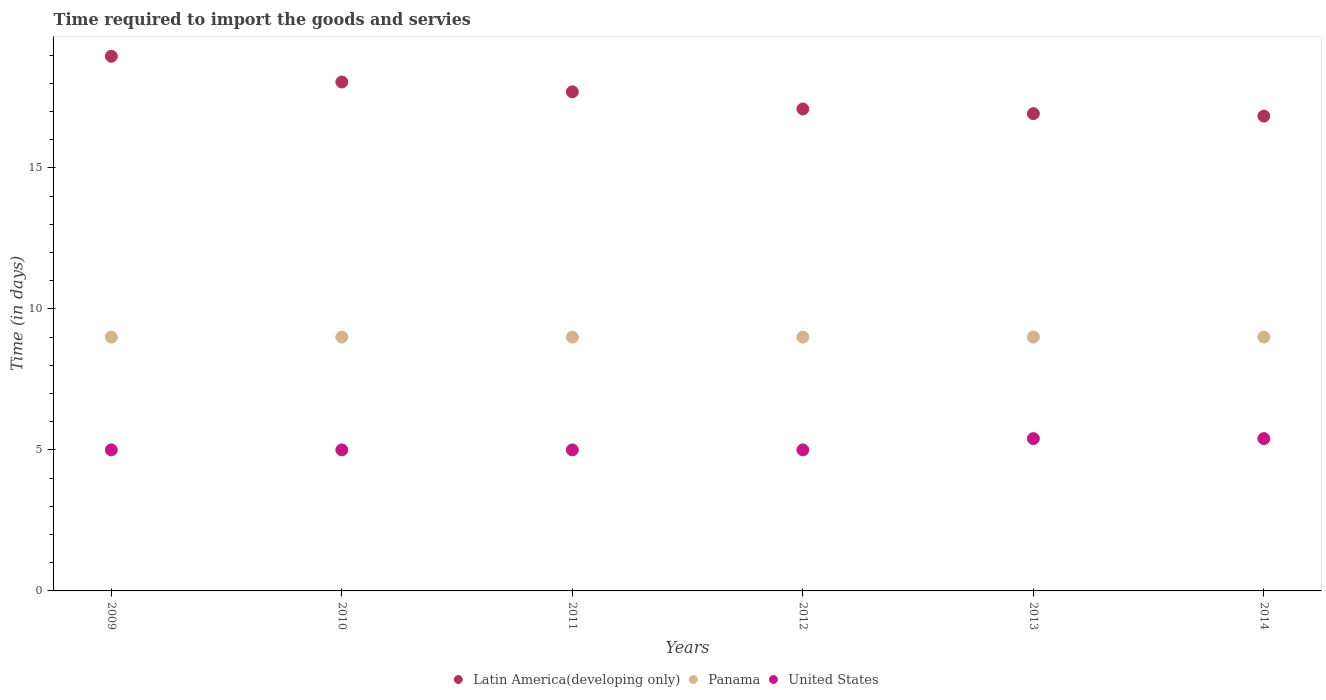How many different coloured dotlines are there?
Keep it short and to the point. 3. What is the number of days required to import the goods and services in Panama in 2009?
Give a very brief answer. 9. Across all years, what is the maximum number of days required to import the goods and services in Panama?
Provide a succinct answer. 9. Across all years, what is the minimum number of days required to import the goods and services in United States?
Give a very brief answer. 5. In which year was the number of days required to import the goods and services in United States maximum?
Make the answer very short. 2013. In which year was the number of days required to import the goods and services in Panama minimum?
Give a very brief answer. 2009. What is the total number of days required to import the goods and services in Latin America(developing only) in the graph?
Provide a succinct answer. 105.54. What is the difference between the number of days required to import the goods and services in Latin America(developing only) in 2011 and the number of days required to import the goods and services in Panama in 2013?
Keep it short and to the point. 8.7. What is the average number of days required to import the goods and services in Latin America(developing only) per year?
Provide a succinct answer. 17.59. In the year 2013, what is the difference between the number of days required to import the goods and services in United States and number of days required to import the goods and services in Latin America(developing only)?
Your response must be concise. -11.52. Is the number of days required to import the goods and services in United States in 2012 less than that in 2014?
Keep it short and to the point. Yes. What is the difference between the highest and the second highest number of days required to import the goods and services in United States?
Your response must be concise. 0. What is the difference between the highest and the lowest number of days required to import the goods and services in United States?
Make the answer very short. 0.4. In how many years, is the number of days required to import the goods and services in Latin America(developing only) greater than the average number of days required to import the goods and services in Latin America(developing only) taken over all years?
Provide a succinct answer. 3. Is the sum of the number of days required to import the goods and services in Panama in 2010 and 2012 greater than the maximum number of days required to import the goods and services in Latin America(developing only) across all years?
Keep it short and to the point. No. Is it the case that in every year, the sum of the number of days required to import the goods and services in United States and number of days required to import the goods and services in Panama  is greater than the number of days required to import the goods and services in Latin America(developing only)?
Give a very brief answer. No. Does the number of days required to import the goods and services in United States monotonically increase over the years?
Ensure brevity in your answer.  No. Is the number of days required to import the goods and services in Panama strictly less than the number of days required to import the goods and services in Latin America(developing only) over the years?
Offer a terse response. Yes. How many years are there in the graph?
Your response must be concise. 6. What is the difference between two consecutive major ticks on the Y-axis?
Keep it short and to the point. 5. Are the values on the major ticks of Y-axis written in scientific E-notation?
Keep it short and to the point. No. Does the graph contain grids?
Keep it short and to the point. No. What is the title of the graph?
Your answer should be very brief. Time required to import the goods and servies. Does "Middle income" appear as one of the legend labels in the graph?
Provide a short and direct response. No. What is the label or title of the Y-axis?
Ensure brevity in your answer.  Time (in days). What is the Time (in days) of Latin America(developing only) in 2009?
Ensure brevity in your answer.  18.96. What is the Time (in days) in Panama in 2009?
Offer a terse response. 9. What is the Time (in days) in United States in 2009?
Offer a very short reply. 5. What is the Time (in days) of Latin America(developing only) in 2010?
Make the answer very short. 18.04. What is the Time (in days) in Latin America(developing only) in 2011?
Offer a terse response. 17.7. What is the Time (in days) in United States in 2011?
Your response must be concise. 5. What is the Time (in days) of Latin America(developing only) in 2012?
Your answer should be compact. 17.09. What is the Time (in days) of Latin America(developing only) in 2013?
Provide a short and direct response. 16.92. What is the Time (in days) in Panama in 2013?
Provide a succinct answer. 9. What is the Time (in days) in United States in 2013?
Your answer should be very brief. 5.4. What is the Time (in days) in Latin America(developing only) in 2014?
Your answer should be compact. 16.83. What is the Time (in days) in Panama in 2014?
Your answer should be compact. 9. Across all years, what is the maximum Time (in days) in Latin America(developing only)?
Offer a terse response. 18.96. Across all years, what is the maximum Time (in days) in Panama?
Your response must be concise. 9. Across all years, what is the maximum Time (in days) in United States?
Offer a very short reply. 5.4. Across all years, what is the minimum Time (in days) of Latin America(developing only)?
Make the answer very short. 16.83. What is the total Time (in days) of Latin America(developing only) in the graph?
Provide a short and direct response. 105.54. What is the total Time (in days) of Panama in the graph?
Your response must be concise. 54. What is the total Time (in days) in United States in the graph?
Offer a very short reply. 30.8. What is the difference between the Time (in days) of Panama in 2009 and that in 2010?
Your answer should be very brief. 0. What is the difference between the Time (in days) in United States in 2009 and that in 2010?
Offer a terse response. 0. What is the difference between the Time (in days) of Latin America(developing only) in 2009 and that in 2011?
Offer a terse response. 1.26. What is the difference between the Time (in days) in Panama in 2009 and that in 2011?
Make the answer very short. 0. What is the difference between the Time (in days) in United States in 2009 and that in 2011?
Your response must be concise. 0. What is the difference between the Time (in days) in Latin America(developing only) in 2009 and that in 2012?
Provide a short and direct response. 1.87. What is the difference between the Time (in days) of Panama in 2009 and that in 2012?
Your answer should be compact. 0. What is the difference between the Time (in days) in Latin America(developing only) in 2009 and that in 2013?
Provide a short and direct response. 2.03. What is the difference between the Time (in days) in Latin America(developing only) in 2009 and that in 2014?
Keep it short and to the point. 2.12. What is the difference between the Time (in days) of Latin America(developing only) in 2010 and that in 2011?
Provide a short and direct response. 0.35. What is the difference between the Time (in days) in United States in 2010 and that in 2011?
Your answer should be compact. 0. What is the difference between the Time (in days) of Latin America(developing only) in 2010 and that in 2012?
Your answer should be very brief. 0.96. What is the difference between the Time (in days) of United States in 2010 and that in 2012?
Offer a very short reply. 0. What is the difference between the Time (in days) in Latin America(developing only) in 2010 and that in 2013?
Provide a succinct answer. 1.12. What is the difference between the Time (in days) in Panama in 2010 and that in 2013?
Give a very brief answer. 0. What is the difference between the Time (in days) in Latin America(developing only) in 2010 and that in 2014?
Give a very brief answer. 1.21. What is the difference between the Time (in days) in Panama in 2010 and that in 2014?
Keep it short and to the point. 0. What is the difference between the Time (in days) of Latin America(developing only) in 2011 and that in 2012?
Make the answer very short. 0.61. What is the difference between the Time (in days) of Panama in 2011 and that in 2012?
Offer a terse response. 0. What is the difference between the Time (in days) in United States in 2011 and that in 2012?
Give a very brief answer. 0. What is the difference between the Time (in days) in Latin America(developing only) in 2011 and that in 2013?
Offer a very short reply. 0.77. What is the difference between the Time (in days) in United States in 2011 and that in 2013?
Give a very brief answer. -0.4. What is the difference between the Time (in days) of Latin America(developing only) in 2011 and that in 2014?
Your answer should be very brief. 0.86. What is the difference between the Time (in days) of Latin America(developing only) in 2012 and that in 2013?
Ensure brevity in your answer.  0.17. What is the difference between the Time (in days) of United States in 2012 and that in 2013?
Your response must be concise. -0.4. What is the difference between the Time (in days) of Latin America(developing only) in 2012 and that in 2014?
Your answer should be very brief. 0.25. What is the difference between the Time (in days) of Panama in 2012 and that in 2014?
Your answer should be compact. 0. What is the difference between the Time (in days) of Latin America(developing only) in 2013 and that in 2014?
Your answer should be compact. 0.09. What is the difference between the Time (in days) in Panama in 2013 and that in 2014?
Provide a short and direct response. 0. What is the difference between the Time (in days) of United States in 2013 and that in 2014?
Your answer should be compact. 0. What is the difference between the Time (in days) in Latin America(developing only) in 2009 and the Time (in days) in Panama in 2010?
Give a very brief answer. 9.96. What is the difference between the Time (in days) of Latin America(developing only) in 2009 and the Time (in days) of United States in 2010?
Your answer should be compact. 13.96. What is the difference between the Time (in days) of Latin America(developing only) in 2009 and the Time (in days) of Panama in 2011?
Your answer should be very brief. 9.96. What is the difference between the Time (in days) of Latin America(developing only) in 2009 and the Time (in days) of United States in 2011?
Offer a terse response. 13.96. What is the difference between the Time (in days) of Panama in 2009 and the Time (in days) of United States in 2011?
Your response must be concise. 4. What is the difference between the Time (in days) of Latin America(developing only) in 2009 and the Time (in days) of Panama in 2012?
Your response must be concise. 9.96. What is the difference between the Time (in days) in Latin America(developing only) in 2009 and the Time (in days) in United States in 2012?
Keep it short and to the point. 13.96. What is the difference between the Time (in days) in Latin America(developing only) in 2009 and the Time (in days) in Panama in 2013?
Provide a succinct answer. 9.96. What is the difference between the Time (in days) of Latin America(developing only) in 2009 and the Time (in days) of United States in 2013?
Offer a very short reply. 13.56. What is the difference between the Time (in days) in Latin America(developing only) in 2009 and the Time (in days) in Panama in 2014?
Your answer should be compact. 9.96. What is the difference between the Time (in days) of Latin America(developing only) in 2009 and the Time (in days) of United States in 2014?
Provide a short and direct response. 13.56. What is the difference between the Time (in days) of Panama in 2009 and the Time (in days) of United States in 2014?
Offer a terse response. 3.6. What is the difference between the Time (in days) in Latin America(developing only) in 2010 and the Time (in days) in Panama in 2011?
Keep it short and to the point. 9.04. What is the difference between the Time (in days) of Latin America(developing only) in 2010 and the Time (in days) of United States in 2011?
Provide a succinct answer. 13.04. What is the difference between the Time (in days) in Latin America(developing only) in 2010 and the Time (in days) in Panama in 2012?
Keep it short and to the point. 9.04. What is the difference between the Time (in days) in Latin America(developing only) in 2010 and the Time (in days) in United States in 2012?
Make the answer very short. 13.04. What is the difference between the Time (in days) of Panama in 2010 and the Time (in days) of United States in 2012?
Give a very brief answer. 4. What is the difference between the Time (in days) of Latin America(developing only) in 2010 and the Time (in days) of Panama in 2013?
Make the answer very short. 9.04. What is the difference between the Time (in days) in Latin America(developing only) in 2010 and the Time (in days) in United States in 2013?
Your answer should be compact. 12.64. What is the difference between the Time (in days) in Latin America(developing only) in 2010 and the Time (in days) in Panama in 2014?
Offer a terse response. 9.04. What is the difference between the Time (in days) in Latin America(developing only) in 2010 and the Time (in days) in United States in 2014?
Offer a terse response. 12.64. What is the difference between the Time (in days) of Latin America(developing only) in 2011 and the Time (in days) of Panama in 2012?
Offer a terse response. 8.7. What is the difference between the Time (in days) in Latin America(developing only) in 2011 and the Time (in days) in United States in 2012?
Offer a terse response. 12.7. What is the difference between the Time (in days) of Panama in 2011 and the Time (in days) of United States in 2012?
Keep it short and to the point. 4. What is the difference between the Time (in days) in Latin America(developing only) in 2011 and the Time (in days) in Panama in 2013?
Provide a short and direct response. 8.7. What is the difference between the Time (in days) of Latin America(developing only) in 2011 and the Time (in days) of United States in 2013?
Make the answer very short. 12.3. What is the difference between the Time (in days) of Panama in 2011 and the Time (in days) of United States in 2013?
Make the answer very short. 3.6. What is the difference between the Time (in days) in Latin America(developing only) in 2011 and the Time (in days) in Panama in 2014?
Offer a very short reply. 8.7. What is the difference between the Time (in days) of Latin America(developing only) in 2011 and the Time (in days) of United States in 2014?
Offer a very short reply. 12.3. What is the difference between the Time (in days) in Panama in 2011 and the Time (in days) in United States in 2014?
Make the answer very short. 3.6. What is the difference between the Time (in days) in Latin America(developing only) in 2012 and the Time (in days) in Panama in 2013?
Your response must be concise. 8.09. What is the difference between the Time (in days) in Latin America(developing only) in 2012 and the Time (in days) in United States in 2013?
Keep it short and to the point. 11.69. What is the difference between the Time (in days) of Latin America(developing only) in 2012 and the Time (in days) of Panama in 2014?
Your answer should be very brief. 8.09. What is the difference between the Time (in days) in Latin America(developing only) in 2012 and the Time (in days) in United States in 2014?
Offer a terse response. 11.69. What is the difference between the Time (in days) of Latin America(developing only) in 2013 and the Time (in days) of Panama in 2014?
Ensure brevity in your answer.  7.92. What is the difference between the Time (in days) of Latin America(developing only) in 2013 and the Time (in days) of United States in 2014?
Your answer should be compact. 11.52. What is the difference between the Time (in days) of Panama in 2013 and the Time (in days) of United States in 2014?
Offer a terse response. 3.6. What is the average Time (in days) of Latin America(developing only) per year?
Your answer should be very brief. 17.59. What is the average Time (in days) of United States per year?
Give a very brief answer. 5.13. In the year 2009, what is the difference between the Time (in days) in Latin America(developing only) and Time (in days) in Panama?
Your response must be concise. 9.96. In the year 2009, what is the difference between the Time (in days) in Latin America(developing only) and Time (in days) in United States?
Make the answer very short. 13.96. In the year 2009, what is the difference between the Time (in days) in Panama and Time (in days) in United States?
Your answer should be very brief. 4. In the year 2010, what is the difference between the Time (in days) in Latin America(developing only) and Time (in days) in Panama?
Your response must be concise. 9.04. In the year 2010, what is the difference between the Time (in days) in Latin America(developing only) and Time (in days) in United States?
Provide a succinct answer. 13.04. In the year 2010, what is the difference between the Time (in days) of Panama and Time (in days) of United States?
Give a very brief answer. 4. In the year 2011, what is the difference between the Time (in days) of Latin America(developing only) and Time (in days) of Panama?
Make the answer very short. 8.7. In the year 2011, what is the difference between the Time (in days) of Latin America(developing only) and Time (in days) of United States?
Offer a terse response. 12.7. In the year 2011, what is the difference between the Time (in days) in Panama and Time (in days) in United States?
Keep it short and to the point. 4. In the year 2012, what is the difference between the Time (in days) in Latin America(developing only) and Time (in days) in Panama?
Make the answer very short. 8.09. In the year 2012, what is the difference between the Time (in days) in Latin America(developing only) and Time (in days) in United States?
Make the answer very short. 12.09. In the year 2013, what is the difference between the Time (in days) of Latin America(developing only) and Time (in days) of Panama?
Provide a short and direct response. 7.92. In the year 2013, what is the difference between the Time (in days) in Latin America(developing only) and Time (in days) in United States?
Your response must be concise. 11.52. In the year 2014, what is the difference between the Time (in days) in Latin America(developing only) and Time (in days) in Panama?
Your answer should be very brief. 7.83. In the year 2014, what is the difference between the Time (in days) in Latin America(developing only) and Time (in days) in United States?
Offer a very short reply. 11.43. What is the ratio of the Time (in days) in Latin America(developing only) in 2009 to that in 2010?
Offer a very short reply. 1.05. What is the ratio of the Time (in days) of United States in 2009 to that in 2010?
Make the answer very short. 1. What is the ratio of the Time (in days) of Latin America(developing only) in 2009 to that in 2011?
Provide a short and direct response. 1.07. What is the ratio of the Time (in days) of Latin America(developing only) in 2009 to that in 2012?
Offer a terse response. 1.11. What is the ratio of the Time (in days) in Latin America(developing only) in 2009 to that in 2013?
Give a very brief answer. 1.12. What is the ratio of the Time (in days) of United States in 2009 to that in 2013?
Offer a terse response. 0.93. What is the ratio of the Time (in days) in Latin America(developing only) in 2009 to that in 2014?
Offer a very short reply. 1.13. What is the ratio of the Time (in days) of United States in 2009 to that in 2014?
Provide a short and direct response. 0.93. What is the ratio of the Time (in days) of Latin America(developing only) in 2010 to that in 2011?
Ensure brevity in your answer.  1.02. What is the ratio of the Time (in days) of Panama in 2010 to that in 2011?
Provide a short and direct response. 1. What is the ratio of the Time (in days) in Latin America(developing only) in 2010 to that in 2012?
Offer a terse response. 1.06. What is the ratio of the Time (in days) in Panama in 2010 to that in 2012?
Ensure brevity in your answer.  1. What is the ratio of the Time (in days) in United States in 2010 to that in 2012?
Keep it short and to the point. 1. What is the ratio of the Time (in days) in Latin America(developing only) in 2010 to that in 2013?
Make the answer very short. 1.07. What is the ratio of the Time (in days) in United States in 2010 to that in 2013?
Give a very brief answer. 0.93. What is the ratio of the Time (in days) of Latin America(developing only) in 2010 to that in 2014?
Provide a succinct answer. 1.07. What is the ratio of the Time (in days) of Panama in 2010 to that in 2014?
Provide a short and direct response. 1. What is the ratio of the Time (in days) of United States in 2010 to that in 2014?
Make the answer very short. 0.93. What is the ratio of the Time (in days) of Latin America(developing only) in 2011 to that in 2012?
Keep it short and to the point. 1.04. What is the ratio of the Time (in days) in Panama in 2011 to that in 2012?
Ensure brevity in your answer.  1. What is the ratio of the Time (in days) of United States in 2011 to that in 2012?
Make the answer very short. 1. What is the ratio of the Time (in days) of Latin America(developing only) in 2011 to that in 2013?
Your answer should be very brief. 1.05. What is the ratio of the Time (in days) in Panama in 2011 to that in 2013?
Offer a terse response. 1. What is the ratio of the Time (in days) of United States in 2011 to that in 2013?
Your response must be concise. 0.93. What is the ratio of the Time (in days) of Latin America(developing only) in 2011 to that in 2014?
Provide a succinct answer. 1.05. What is the ratio of the Time (in days) in Panama in 2011 to that in 2014?
Your answer should be compact. 1. What is the ratio of the Time (in days) of United States in 2011 to that in 2014?
Provide a succinct answer. 0.93. What is the ratio of the Time (in days) of Latin America(developing only) in 2012 to that in 2013?
Keep it short and to the point. 1.01. What is the ratio of the Time (in days) of United States in 2012 to that in 2013?
Provide a short and direct response. 0.93. What is the ratio of the Time (in days) in United States in 2012 to that in 2014?
Give a very brief answer. 0.93. What is the ratio of the Time (in days) of United States in 2013 to that in 2014?
Offer a terse response. 1. What is the difference between the highest and the second highest Time (in days) in Latin America(developing only)?
Give a very brief answer. 0.91. What is the difference between the highest and the second highest Time (in days) of Panama?
Provide a succinct answer. 0. What is the difference between the highest and the second highest Time (in days) in United States?
Give a very brief answer. 0. What is the difference between the highest and the lowest Time (in days) of Latin America(developing only)?
Give a very brief answer. 2.12. What is the difference between the highest and the lowest Time (in days) of Panama?
Give a very brief answer. 0. What is the difference between the highest and the lowest Time (in days) of United States?
Give a very brief answer. 0.4. 